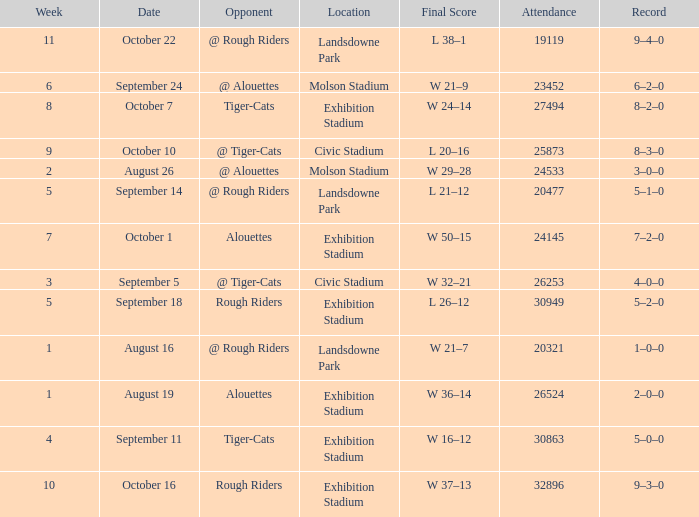How many values for attendance on the date of August 26? 1.0. 